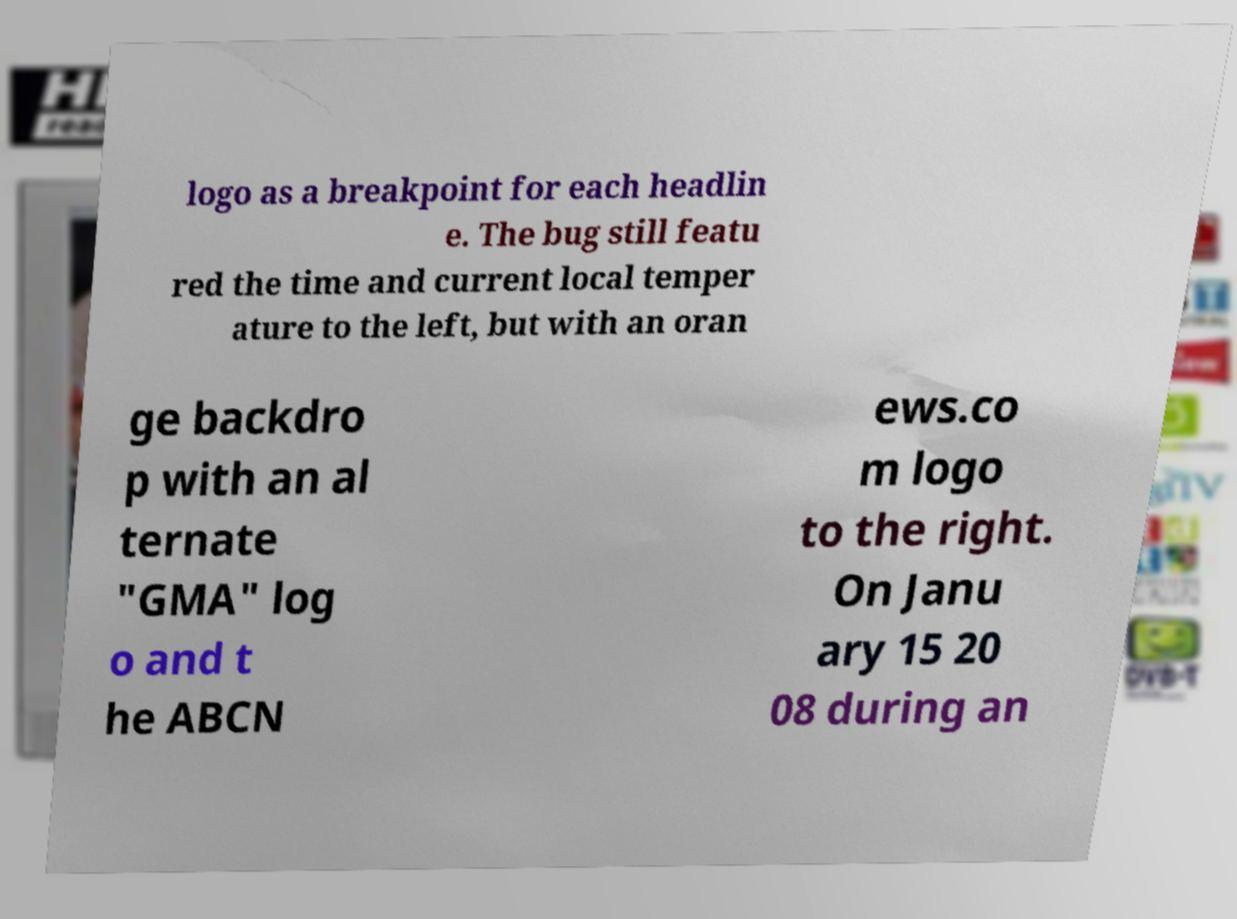Can you accurately transcribe the text from the provided image for me? logo as a breakpoint for each headlin e. The bug still featu red the time and current local temper ature to the left, but with an oran ge backdro p with an al ternate "GMA" log o and t he ABCN ews.co m logo to the right. On Janu ary 15 20 08 during an 